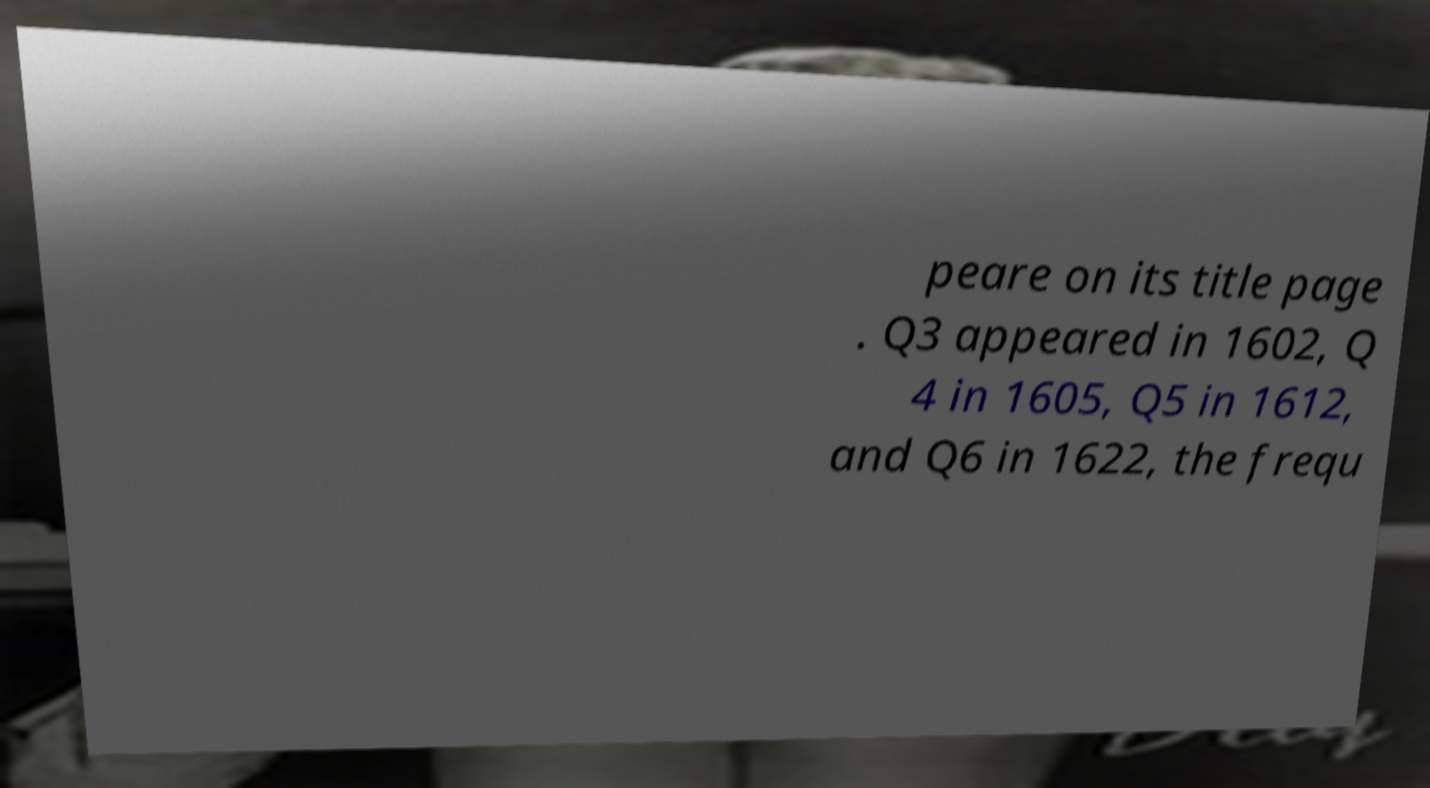Could you assist in decoding the text presented in this image and type it out clearly? peare on its title page . Q3 appeared in 1602, Q 4 in 1605, Q5 in 1612, and Q6 in 1622, the frequ 